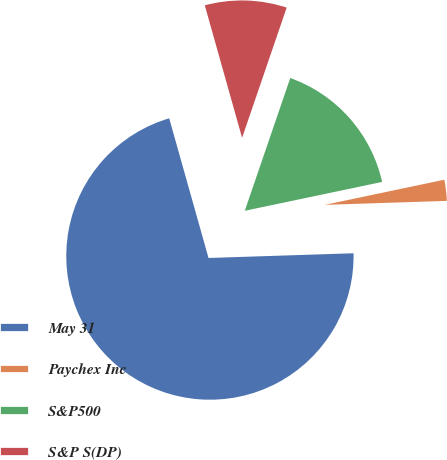Convert chart to OTSL. <chart><loc_0><loc_0><loc_500><loc_500><pie_chart><fcel>May 31<fcel>Paychex Inc<fcel>S&P500<fcel>S&P S(DP)<nl><fcel>71.15%<fcel>2.78%<fcel>16.45%<fcel>9.62%<nl></chart> 